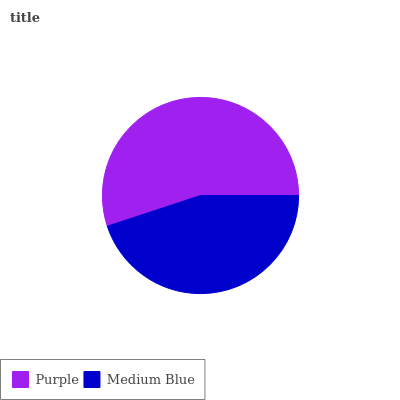Is Medium Blue the minimum?
Answer yes or no. Yes. Is Purple the maximum?
Answer yes or no. Yes. Is Medium Blue the maximum?
Answer yes or no. No. Is Purple greater than Medium Blue?
Answer yes or no. Yes. Is Medium Blue less than Purple?
Answer yes or no. Yes. Is Medium Blue greater than Purple?
Answer yes or no. No. Is Purple less than Medium Blue?
Answer yes or no. No. Is Purple the high median?
Answer yes or no. Yes. Is Medium Blue the low median?
Answer yes or no. Yes. Is Medium Blue the high median?
Answer yes or no. No. Is Purple the low median?
Answer yes or no. No. 